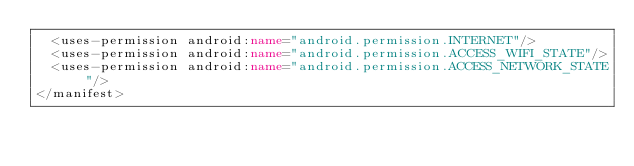<code> <loc_0><loc_0><loc_500><loc_500><_XML_>	<uses-permission android:name="android.permission.INTERNET"/>
	<uses-permission android:name="android.permission.ACCESS_WIFI_STATE"/>
	<uses-permission android:name="android.permission.ACCESS_NETWORK_STATE"/>
</manifest>
</code> 